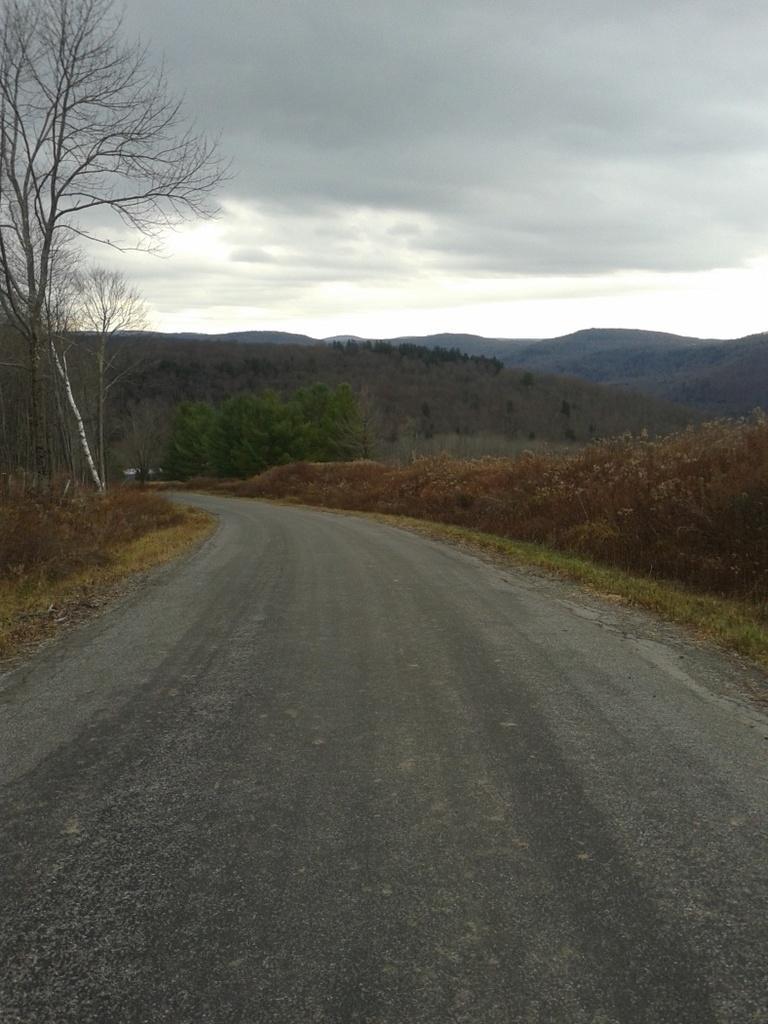How would you summarize this image in a sentence or two? There is a road. On both sides of this road, there are plants and grass on the ground. In the background, there are trees on the mountains and there are clouds in the sky. 